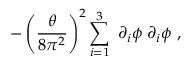Convert formula to latex. <formula><loc_0><loc_0><loc_500><loc_500>- \left ( \frac { \theta } { 8 \pi ^ { 2 } } \right ) ^ { 2 } \sum _ { i = 1 } ^ { 3 } \, \partial _ { i } \phi \, \partial _ { i } \phi ,</formula> 